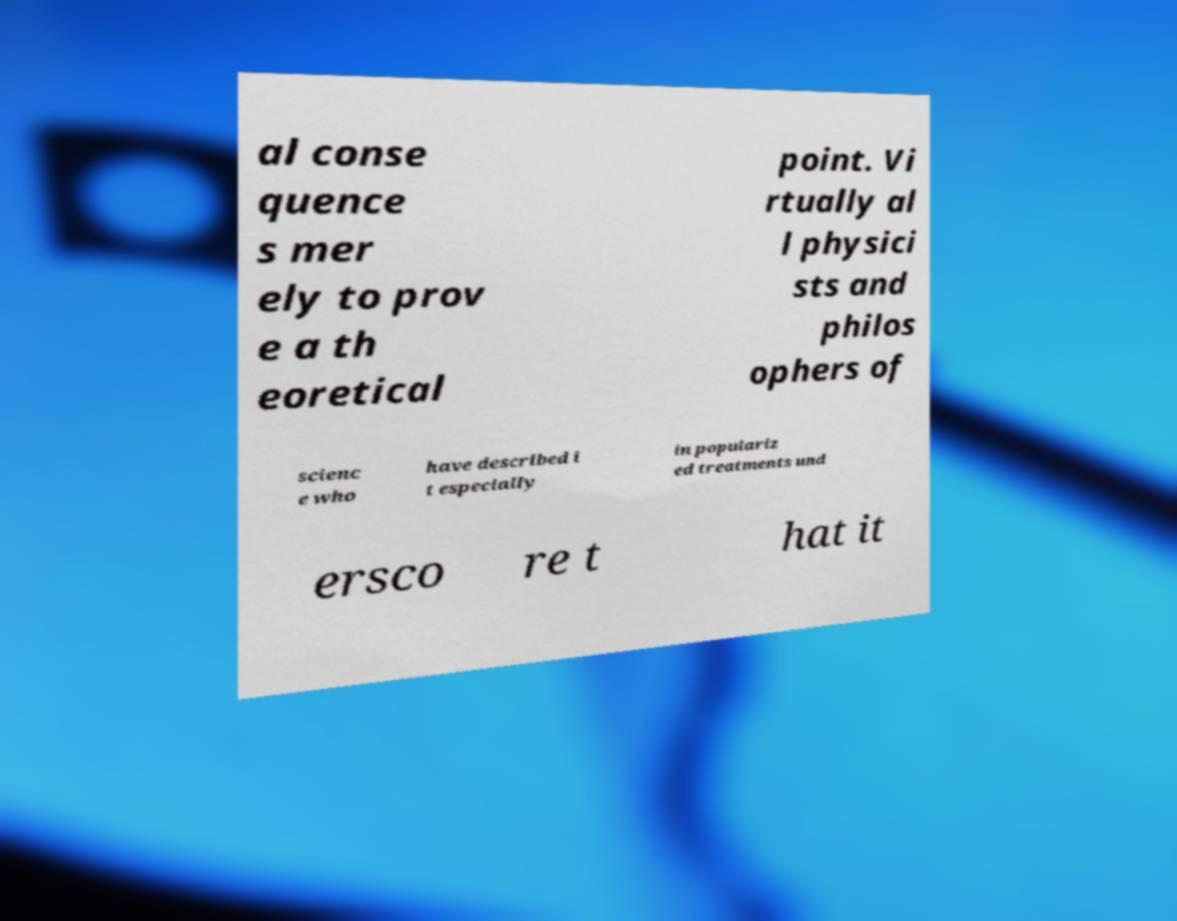Can you read and provide the text displayed in the image?This photo seems to have some interesting text. Can you extract and type it out for me? al conse quence s mer ely to prov e a th eoretical point. Vi rtually al l physici sts and philos ophers of scienc e who have described i t especially in populariz ed treatments und ersco re t hat it 